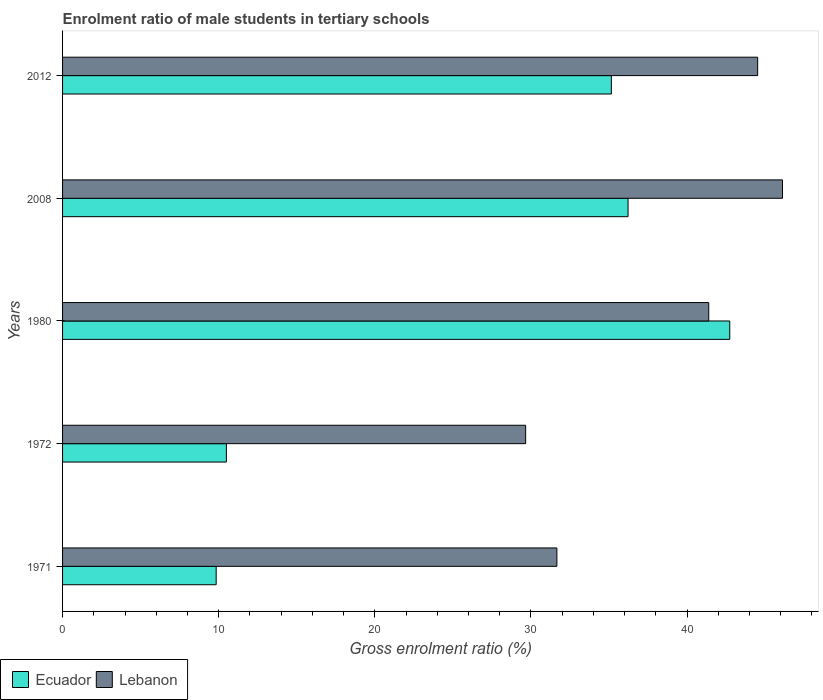How many different coloured bars are there?
Your answer should be very brief. 2. Are the number of bars per tick equal to the number of legend labels?
Provide a short and direct response. Yes. How many bars are there on the 2nd tick from the top?
Your response must be concise. 2. How many bars are there on the 2nd tick from the bottom?
Ensure brevity in your answer.  2. What is the enrolment ratio of male students in tertiary schools in Ecuador in 2012?
Your answer should be very brief. 35.15. Across all years, what is the maximum enrolment ratio of male students in tertiary schools in Ecuador?
Give a very brief answer. 42.74. Across all years, what is the minimum enrolment ratio of male students in tertiary schools in Ecuador?
Ensure brevity in your answer.  9.84. What is the total enrolment ratio of male students in tertiary schools in Lebanon in the graph?
Give a very brief answer. 193.36. What is the difference between the enrolment ratio of male students in tertiary schools in Ecuador in 1980 and that in 2008?
Give a very brief answer. 6.51. What is the difference between the enrolment ratio of male students in tertiary schools in Lebanon in 1971 and the enrolment ratio of male students in tertiary schools in Ecuador in 2012?
Keep it short and to the point. -3.49. What is the average enrolment ratio of male students in tertiary schools in Lebanon per year?
Ensure brevity in your answer.  38.67. In the year 2008, what is the difference between the enrolment ratio of male students in tertiary schools in Lebanon and enrolment ratio of male students in tertiary schools in Ecuador?
Your response must be concise. 9.89. What is the ratio of the enrolment ratio of male students in tertiary schools in Ecuador in 1972 to that in 1980?
Make the answer very short. 0.25. Is the difference between the enrolment ratio of male students in tertiary schools in Lebanon in 2008 and 2012 greater than the difference between the enrolment ratio of male students in tertiary schools in Ecuador in 2008 and 2012?
Offer a very short reply. Yes. What is the difference between the highest and the second highest enrolment ratio of male students in tertiary schools in Ecuador?
Give a very brief answer. 6.51. What is the difference between the highest and the lowest enrolment ratio of male students in tertiary schools in Ecuador?
Your response must be concise. 32.9. In how many years, is the enrolment ratio of male students in tertiary schools in Lebanon greater than the average enrolment ratio of male students in tertiary schools in Lebanon taken over all years?
Give a very brief answer. 3. What does the 2nd bar from the top in 2008 represents?
Offer a very short reply. Ecuador. What does the 1st bar from the bottom in 2008 represents?
Make the answer very short. Ecuador. How many bars are there?
Your response must be concise. 10. Are all the bars in the graph horizontal?
Your answer should be compact. Yes. How many years are there in the graph?
Make the answer very short. 5. Are the values on the major ticks of X-axis written in scientific E-notation?
Give a very brief answer. No. Where does the legend appear in the graph?
Provide a succinct answer. Bottom left. How many legend labels are there?
Your response must be concise. 2. What is the title of the graph?
Keep it short and to the point. Enrolment ratio of male students in tertiary schools. What is the label or title of the X-axis?
Offer a terse response. Gross enrolment ratio (%). What is the Gross enrolment ratio (%) in Ecuador in 1971?
Offer a terse response. 9.84. What is the Gross enrolment ratio (%) in Lebanon in 1971?
Keep it short and to the point. 31.66. What is the Gross enrolment ratio (%) of Ecuador in 1972?
Give a very brief answer. 10.49. What is the Gross enrolment ratio (%) in Lebanon in 1972?
Offer a very short reply. 29.66. What is the Gross enrolment ratio (%) of Ecuador in 1980?
Offer a terse response. 42.74. What is the Gross enrolment ratio (%) of Lebanon in 1980?
Your response must be concise. 41.39. What is the Gross enrolment ratio (%) of Ecuador in 2008?
Make the answer very short. 36.22. What is the Gross enrolment ratio (%) in Lebanon in 2008?
Your answer should be very brief. 46.12. What is the Gross enrolment ratio (%) of Ecuador in 2012?
Give a very brief answer. 35.15. What is the Gross enrolment ratio (%) of Lebanon in 2012?
Provide a short and direct response. 44.52. Across all years, what is the maximum Gross enrolment ratio (%) in Ecuador?
Offer a terse response. 42.74. Across all years, what is the maximum Gross enrolment ratio (%) in Lebanon?
Keep it short and to the point. 46.12. Across all years, what is the minimum Gross enrolment ratio (%) of Ecuador?
Give a very brief answer. 9.84. Across all years, what is the minimum Gross enrolment ratio (%) in Lebanon?
Ensure brevity in your answer.  29.66. What is the total Gross enrolment ratio (%) in Ecuador in the graph?
Your answer should be compact. 134.45. What is the total Gross enrolment ratio (%) of Lebanon in the graph?
Make the answer very short. 193.36. What is the difference between the Gross enrolment ratio (%) in Ecuador in 1971 and that in 1972?
Your answer should be compact. -0.65. What is the difference between the Gross enrolment ratio (%) of Lebanon in 1971 and that in 1972?
Ensure brevity in your answer.  2. What is the difference between the Gross enrolment ratio (%) of Ecuador in 1971 and that in 1980?
Give a very brief answer. -32.9. What is the difference between the Gross enrolment ratio (%) of Lebanon in 1971 and that in 1980?
Offer a very short reply. -9.73. What is the difference between the Gross enrolment ratio (%) of Ecuador in 1971 and that in 2008?
Offer a terse response. -26.38. What is the difference between the Gross enrolment ratio (%) of Lebanon in 1971 and that in 2008?
Ensure brevity in your answer.  -14.45. What is the difference between the Gross enrolment ratio (%) of Ecuador in 1971 and that in 2012?
Offer a terse response. -25.31. What is the difference between the Gross enrolment ratio (%) in Lebanon in 1971 and that in 2012?
Keep it short and to the point. -12.86. What is the difference between the Gross enrolment ratio (%) in Ecuador in 1972 and that in 1980?
Provide a short and direct response. -32.24. What is the difference between the Gross enrolment ratio (%) in Lebanon in 1972 and that in 1980?
Offer a very short reply. -11.73. What is the difference between the Gross enrolment ratio (%) in Ecuador in 1972 and that in 2008?
Give a very brief answer. -25.73. What is the difference between the Gross enrolment ratio (%) in Lebanon in 1972 and that in 2008?
Give a very brief answer. -16.45. What is the difference between the Gross enrolment ratio (%) of Ecuador in 1972 and that in 2012?
Ensure brevity in your answer.  -24.66. What is the difference between the Gross enrolment ratio (%) in Lebanon in 1972 and that in 2012?
Make the answer very short. -14.86. What is the difference between the Gross enrolment ratio (%) of Ecuador in 1980 and that in 2008?
Your answer should be compact. 6.51. What is the difference between the Gross enrolment ratio (%) of Lebanon in 1980 and that in 2008?
Offer a very short reply. -4.72. What is the difference between the Gross enrolment ratio (%) of Ecuador in 1980 and that in 2012?
Your answer should be very brief. 7.58. What is the difference between the Gross enrolment ratio (%) in Lebanon in 1980 and that in 2012?
Your response must be concise. -3.13. What is the difference between the Gross enrolment ratio (%) of Ecuador in 2008 and that in 2012?
Your response must be concise. 1.07. What is the difference between the Gross enrolment ratio (%) of Lebanon in 2008 and that in 2012?
Ensure brevity in your answer.  1.59. What is the difference between the Gross enrolment ratio (%) of Ecuador in 1971 and the Gross enrolment ratio (%) of Lebanon in 1972?
Your answer should be very brief. -19.82. What is the difference between the Gross enrolment ratio (%) of Ecuador in 1971 and the Gross enrolment ratio (%) of Lebanon in 1980?
Offer a very short reply. -31.55. What is the difference between the Gross enrolment ratio (%) in Ecuador in 1971 and the Gross enrolment ratio (%) in Lebanon in 2008?
Your answer should be very brief. -36.28. What is the difference between the Gross enrolment ratio (%) of Ecuador in 1971 and the Gross enrolment ratio (%) of Lebanon in 2012?
Keep it short and to the point. -34.68. What is the difference between the Gross enrolment ratio (%) of Ecuador in 1972 and the Gross enrolment ratio (%) of Lebanon in 1980?
Ensure brevity in your answer.  -30.9. What is the difference between the Gross enrolment ratio (%) in Ecuador in 1972 and the Gross enrolment ratio (%) in Lebanon in 2008?
Your answer should be compact. -35.62. What is the difference between the Gross enrolment ratio (%) of Ecuador in 1972 and the Gross enrolment ratio (%) of Lebanon in 2012?
Your answer should be compact. -34.03. What is the difference between the Gross enrolment ratio (%) in Ecuador in 1980 and the Gross enrolment ratio (%) in Lebanon in 2008?
Offer a terse response. -3.38. What is the difference between the Gross enrolment ratio (%) of Ecuador in 1980 and the Gross enrolment ratio (%) of Lebanon in 2012?
Ensure brevity in your answer.  -1.79. What is the difference between the Gross enrolment ratio (%) in Ecuador in 2008 and the Gross enrolment ratio (%) in Lebanon in 2012?
Keep it short and to the point. -8.3. What is the average Gross enrolment ratio (%) of Ecuador per year?
Offer a very short reply. 26.89. What is the average Gross enrolment ratio (%) of Lebanon per year?
Provide a succinct answer. 38.67. In the year 1971, what is the difference between the Gross enrolment ratio (%) in Ecuador and Gross enrolment ratio (%) in Lebanon?
Give a very brief answer. -21.82. In the year 1972, what is the difference between the Gross enrolment ratio (%) in Ecuador and Gross enrolment ratio (%) in Lebanon?
Keep it short and to the point. -19.17. In the year 1980, what is the difference between the Gross enrolment ratio (%) of Ecuador and Gross enrolment ratio (%) of Lebanon?
Give a very brief answer. 1.35. In the year 2008, what is the difference between the Gross enrolment ratio (%) in Ecuador and Gross enrolment ratio (%) in Lebanon?
Offer a very short reply. -9.89. In the year 2012, what is the difference between the Gross enrolment ratio (%) in Ecuador and Gross enrolment ratio (%) in Lebanon?
Ensure brevity in your answer.  -9.37. What is the ratio of the Gross enrolment ratio (%) of Ecuador in 1971 to that in 1972?
Your answer should be very brief. 0.94. What is the ratio of the Gross enrolment ratio (%) of Lebanon in 1971 to that in 1972?
Offer a terse response. 1.07. What is the ratio of the Gross enrolment ratio (%) of Ecuador in 1971 to that in 1980?
Give a very brief answer. 0.23. What is the ratio of the Gross enrolment ratio (%) in Lebanon in 1971 to that in 1980?
Your answer should be very brief. 0.77. What is the ratio of the Gross enrolment ratio (%) in Ecuador in 1971 to that in 2008?
Offer a very short reply. 0.27. What is the ratio of the Gross enrolment ratio (%) of Lebanon in 1971 to that in 2008?
Give a very brief answer. 0.69. What is the ratio of the Gross enrolment ratio (%) in Ecuador in 1971 to that in 2012?
Ensure brevity in your answer.  0.28. What is the ratio of the Gross enrolment ratio (%) in Lebanon in 1971 to that in 2012?
Your response must be concise. 0.71. What is the ratio of the Gross enrolment ratio (%) of Ecuador in 1972 to that in 1980?
Keep it short and to the point. 0.25. What is the ratio of the Gross enrolment ratio (%) of Lebanon in 1972 to that in 1980?
Give a very brief answer. 0.72. What is the ratio of the Gross enrolment ratio (%) in Ecuador in 1972 to that in 2008?
Your response must be concise. 0.29. What is the ratio of the Gross enrolment ratio (%) in Lebanon in 1972 to that in 2008?
Make the answer very short. 0.64. What is the ratio of the Gross enrolment ratio (%) of Ecuador in 1972 to that in 2012?
Keep it short and to the point. 0.3. What is the ratio of the Gross enrolment ratio (%) of Lebanon in 1972 to that in 2012?
Offer a very short reply. 0.67. What is the ratio of the Gross enrolment ratio (%) in Ecuador in 1980 to that in 2008?
Provide a succinct answer. 1.18. What is the ratio of the Gross enrolment ratio (%) in Lebanon in 1980 to that in 2008?
Ensure brevity in your answer.  0.9. What is the ratio of the Gross enrolment ratio (%) in Ecuador in 1980 to that in 2012?
Offer a terse response. 1.22. What is the ratio of the Gross enrolment ratio (%) in Lebanon in 1980 to that in 2012?
Provide a succinct answer. 0.93. What is the ratio of the Gross enrolment ratio (%) in Ecuador in 2008 to that in 2012?
Your response must be concise. 1.03. What is the ratio of the Gross enrolment ratio (%) in Lebanon in 2008 to that in 2012?
Ensure brevity in your answer.  1.04. What is the difference between the highest and the second highest Gross enrolment ratio (%) in Ecuador?
Your response must be concise. 6.51. What is the difference between the highest and the second highest Gross enrolment ratio (%) in Lebanon?
Give a very brief answer. 1.59. What is the difference between the highest and the lowest Gross enrolment ratio (%) in Ecuador?
Ensure brevity in your answer.  32.9. What is the difference between the highest and the lowest Gross enrolment ratio (%) of Lebanon?
Offer a very short reply. 16.45. 